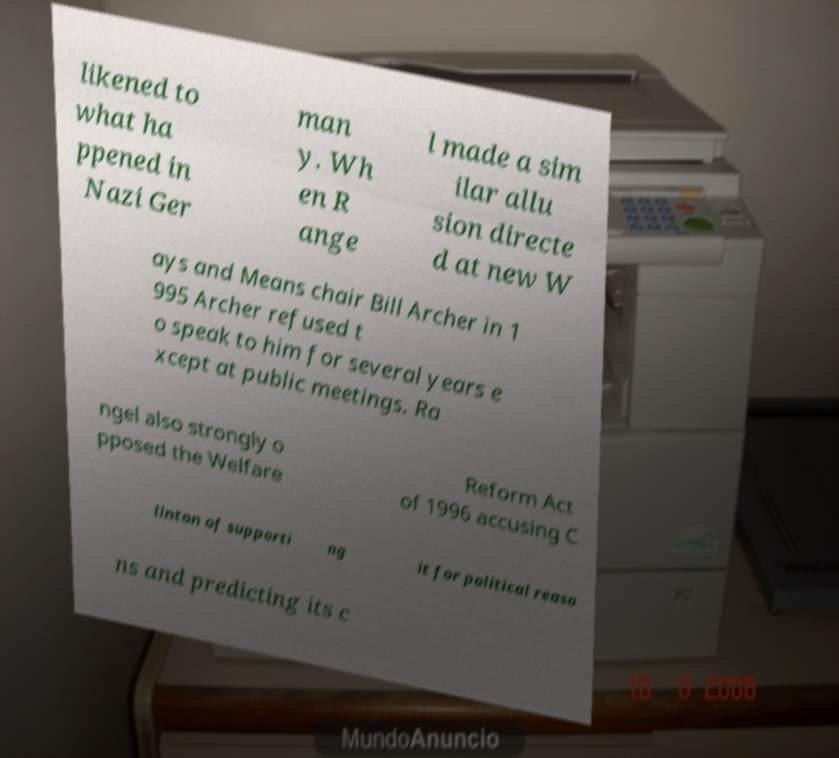What messages or text are displayed in this image? I need them in a readable, typed format. likened to what ha ppened in Nazi Ger man y. Wh en R ange l made a sim ilar allu sion directe d at new W ays and Means chair Bill Archer in 1 995 Archer refused t o speak to him for several years e xcept at public meetings. Ra ngel also strongly o pposed the Welfare Reform Act of 1996 accusing C linton of supporti ng it for political reaso ns and predicting its c 